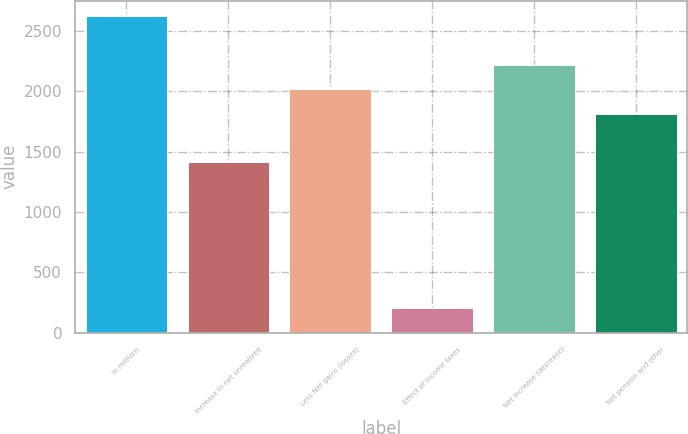Convert chart to OTSL. <chart><loc_0><loc_0><loc_500><loc_500><bar_chart><fcel>In millions<fcel>Increase in net unrealized<fcel>Less Net gains (losses)<fcel>Effect of income taxes<fcel>Net increase (decrease)<fcel>Net pension and other<nl><fcel>2620.9<fcel>1413.1<fcel>2017<fcel>205.3<fcel>2218.3<fcel>1815.7<nl></chart> 